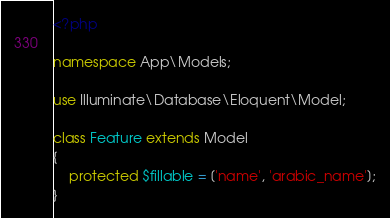Convert code to text. <code><loc_0><loc_0><loc_500><loc_500><_PHP_><?php

namespace App\Models;

use Illuminate\Database\Eloquent\Model;

class Feature extends Model
{
    protected $fillable = ['name', 'arabic_name'];
}
</code> 